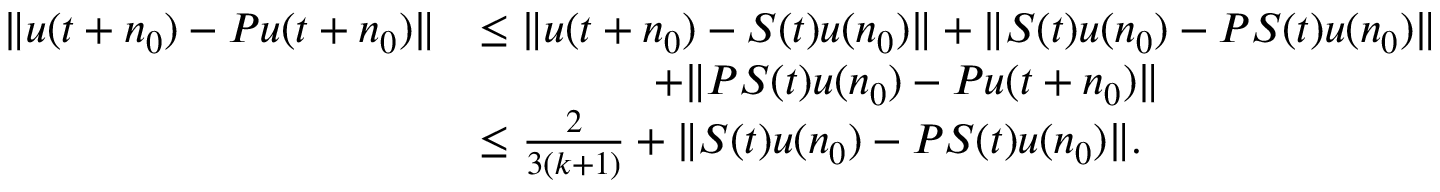Convert formula to latex. <formula><loc_0><loc_0><loc_500><loc_500>\begin{array} { r l } { \| u ( t + n _ { 0 } ) - P u ( t + n _ { 0 } ) \| } & { \leq \| u ( t + n _ { 0 } ) - S ( t ) u ( n _ { 0 } ) \| + \| S ( t ) u ( n _ { 0 } ) - P S ( t ) u ( n _ { 0 } ) \| } \\ & { \quad + \| P S ( t ) u ( n _ { 0 } ) - P u ( t + n _ { 0 } ) \| } \\ & { \leq \frac { 2 } { 3 ( k + 1 ) } + \| S ( t ) u ( n _ { 0 } ) - P S ( t ) u ( n _ { 0 } ) \| . } \end{array}</formula> 